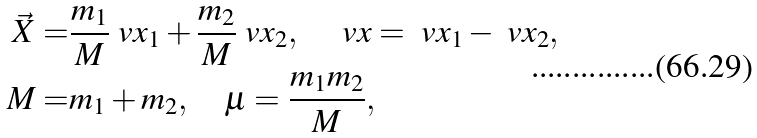Convert formula to latex. <formula><loc_0><loc_0><loc_500><loc_500>\vec { X } = & \frac { m _ { 1 } } { M } \ v x _ { 1 } + \frac { m _ { 2 } } { M } \ v x _ { 2 } , \quad \ v x = \ v x _ { 1 } - \ v x _ { 2 } , \\ M = & m _ { 1 } + m _ { 2 } , \quad \mu = \frac { m _ { 1 } m _ { 2 } } { M } ,</formula> 